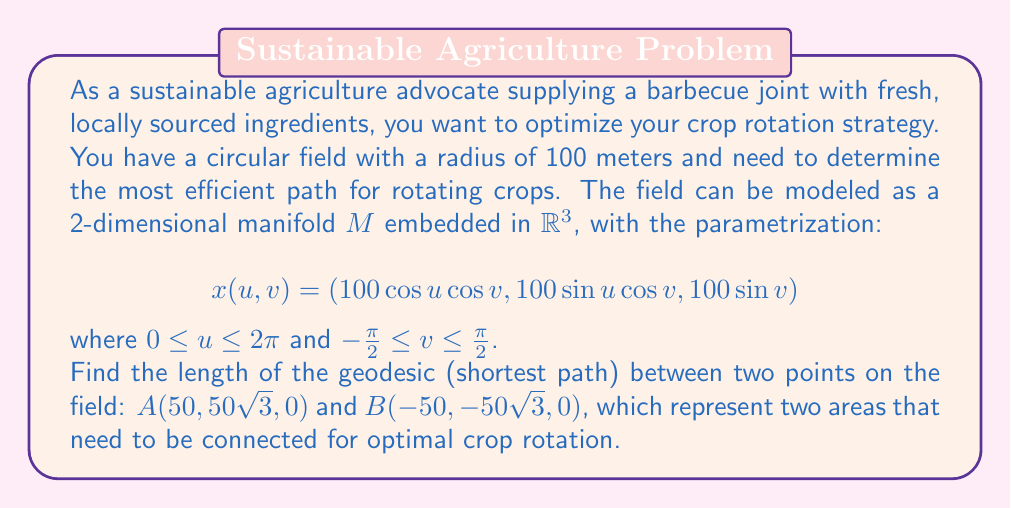Help me with this question. To solve this problem, we'll follow these steps:

1) First, we need to identify the manifold. In this case, it's a sphere with radius 100 meters.

2) The geodesic on a sphere is a great circle, and the shortest path between two points is an arc of this great circle.

3) To find the length of this arc, we need to:
   a) Calculate the angle between the two points from the center of the sphere
   b) Use this angle to determine the length of the arc

4) The angle between two vectors $\vec{OA}$ and $\vec{OB}$ (where O is the origin) can be found using the dot product formula:

   $$\cos \theta = \frac{\vec{OA} \cdot \vec{OB}}{|\vec{OA}||\vec{OB}|}$$

5) In our case:
   $\vec{OA} = (50, 50\sqrt{3}, 0)$
   $\vec{OB} = (-50, -50\sqrt{3}, 0)$

6) Calculating the dot product:
   $$\vec{OA} \cdot \vec{OB} = 50(-50) + 50\sqrt{3}(-50\sqrt{3}) + 0 = -2500 - 7500 = -10000$$

7) The magnitude of both vectors is the radius of the sphere, 100.

8) Substituting into the formula:
   $$\cos \theta = \frac{-10000}{100 \cdot 100} = -1$$

9) Therefore, $\theta = \arccos(-1) = \pi$ radians or 180 degrees.

10) The length of the arc is given by $s = r\theta$, where $r$ is the radius and $\theta$ is in radians.

11) Thus, the length of the geodesic is:
    $$s = 100 \pi \approx 314.16 \text{ meters}$$
Answer: The length of the geodesic (shortest path) between points A and B on the field is $100\pi$ meters, or approximately 314.16 meters. 